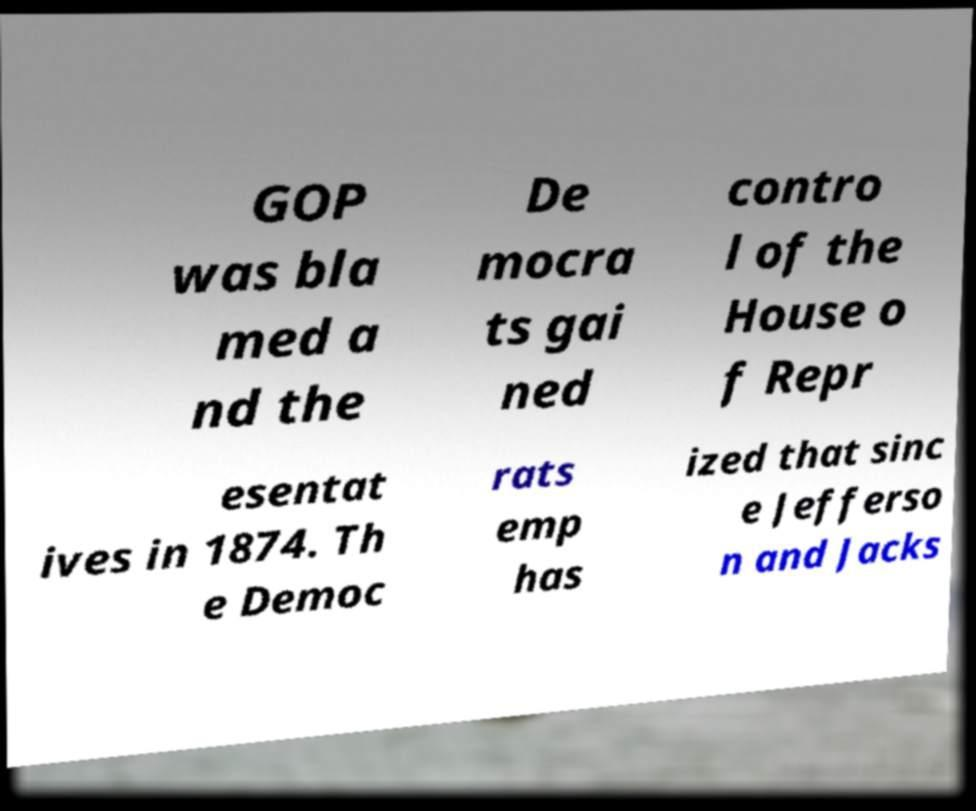I need the written content from this picture converted into text. Can you do that? GOP was bla med a nd the De mocra ts gai ned contro l of the House o f Repr esentat ives in 1874. Th e Democ rats emp has ized that sinc e Jefferso n and Jacks 